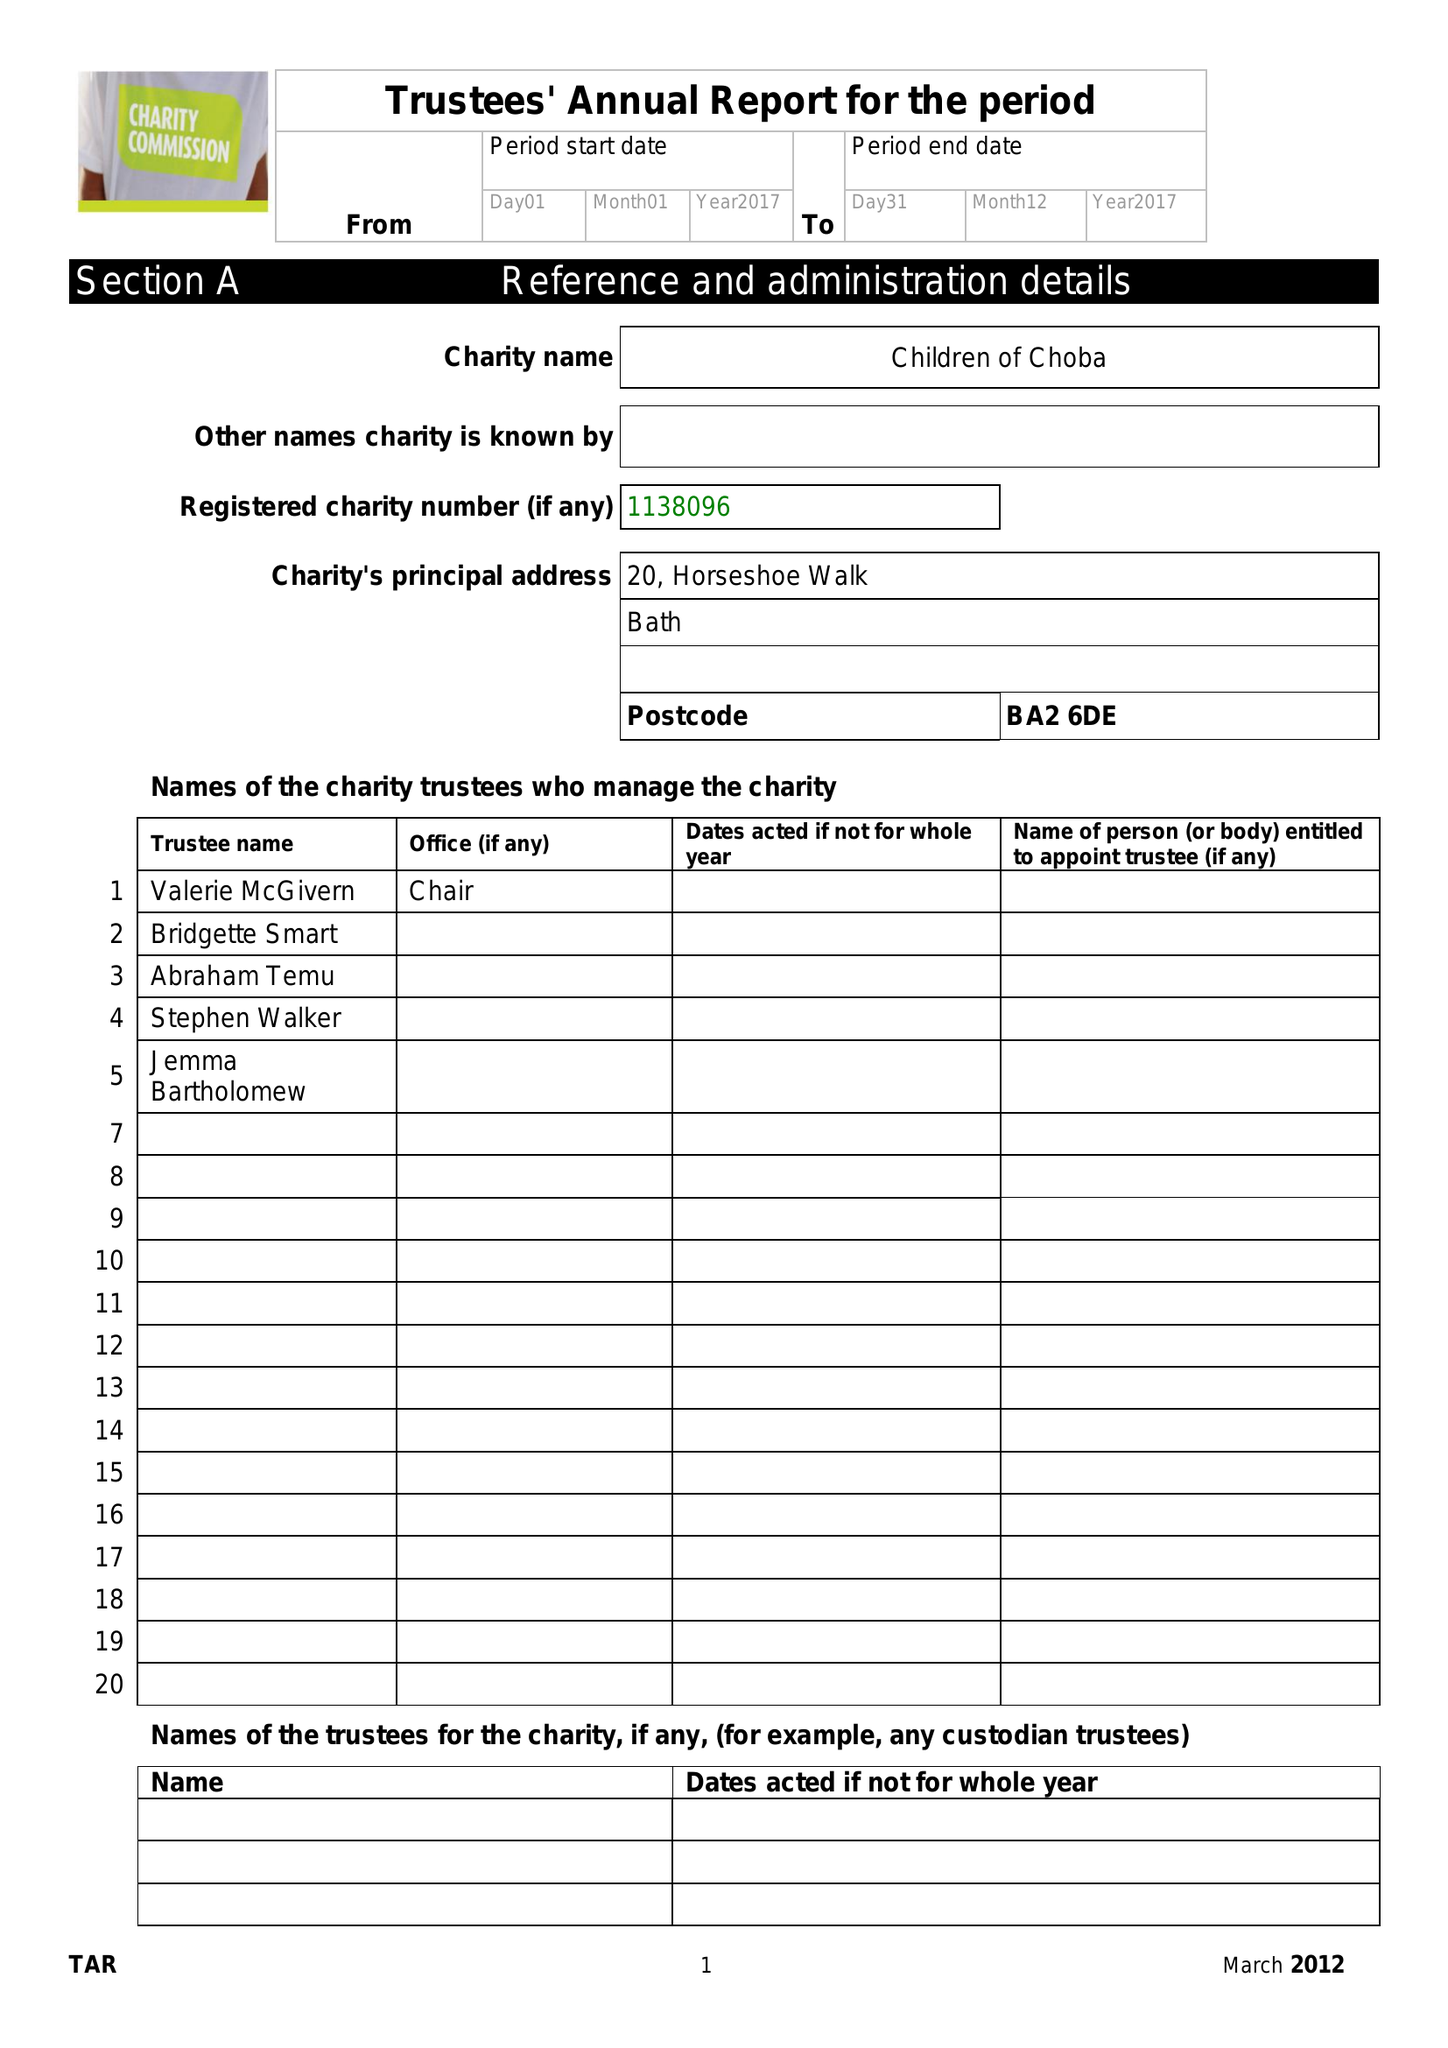What is the value for the charity_name?
Answer the question using a single word or phrase. Children Of Choba 